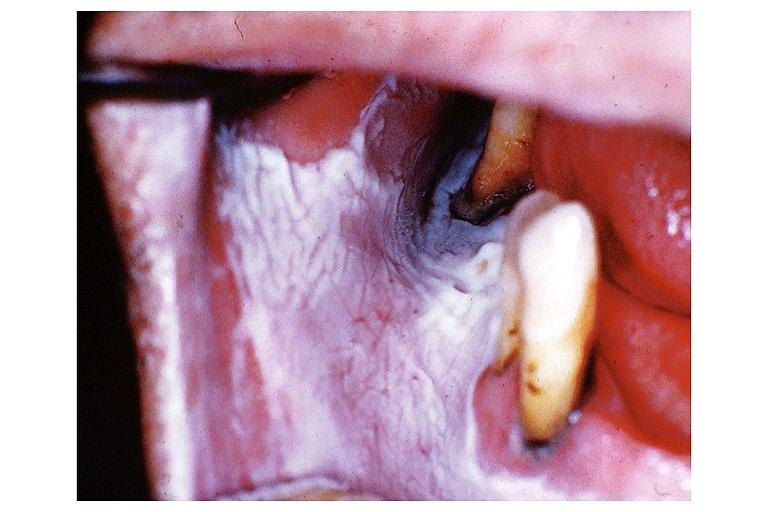s previous slide from this case present?
Answer the question using a single word or phrase. No 